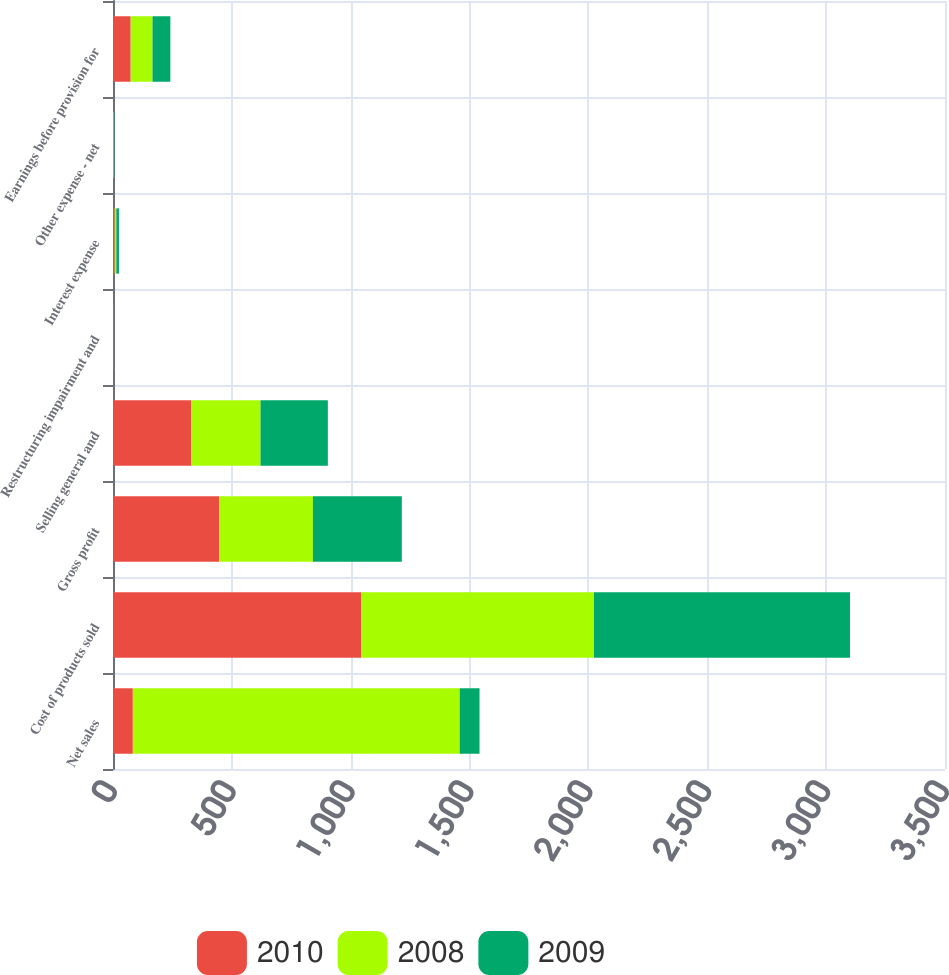Convert chart. <chart><loc_0><loc_0><loc_500><loc_500><stacked_bar_chart><ecel><fcel>Net sales<fcel>Cost of products sold<fcel>Gross profit<fcel>Selling general and<fcel>Restructuring impairment and<fcel>Interest expense<fcel>Other expense - net<fcel>Earnings before provision for<nl><fcel>2010<fcel>83.45<fcel>1043.3<fcel>446<fcel>328.7<fcel>0.1<fcel>6.9<fcel>0.5<fcel>74.4<nl><fcel>2008<fcel>1375<fcel>980.1<fcel>394.9<fcel>291.8<fcel>1.3<fcel>7.2<fcel>2.8<fcel>91.8<nl><fcel>2009<fcel>83.45<fcel>1077.2<fcel>374.1<fcel>283.3<fcel>2.4<fcel>11<fcel>2.3<fcel>75.1<nl></chart> 